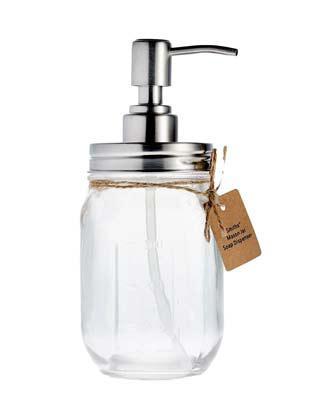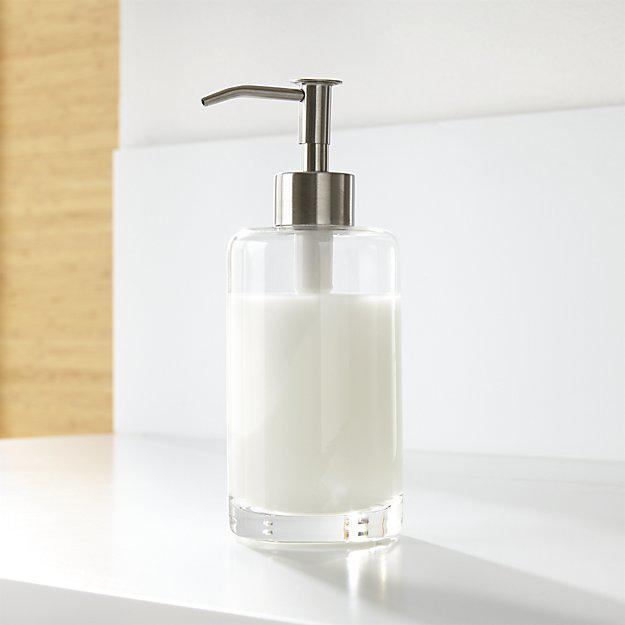The first image is the image on the left, the second image is the image on the right. For the images shown, is this caption "In one image soap is coming out of the dispenser." true? Answer yes or no. No. 